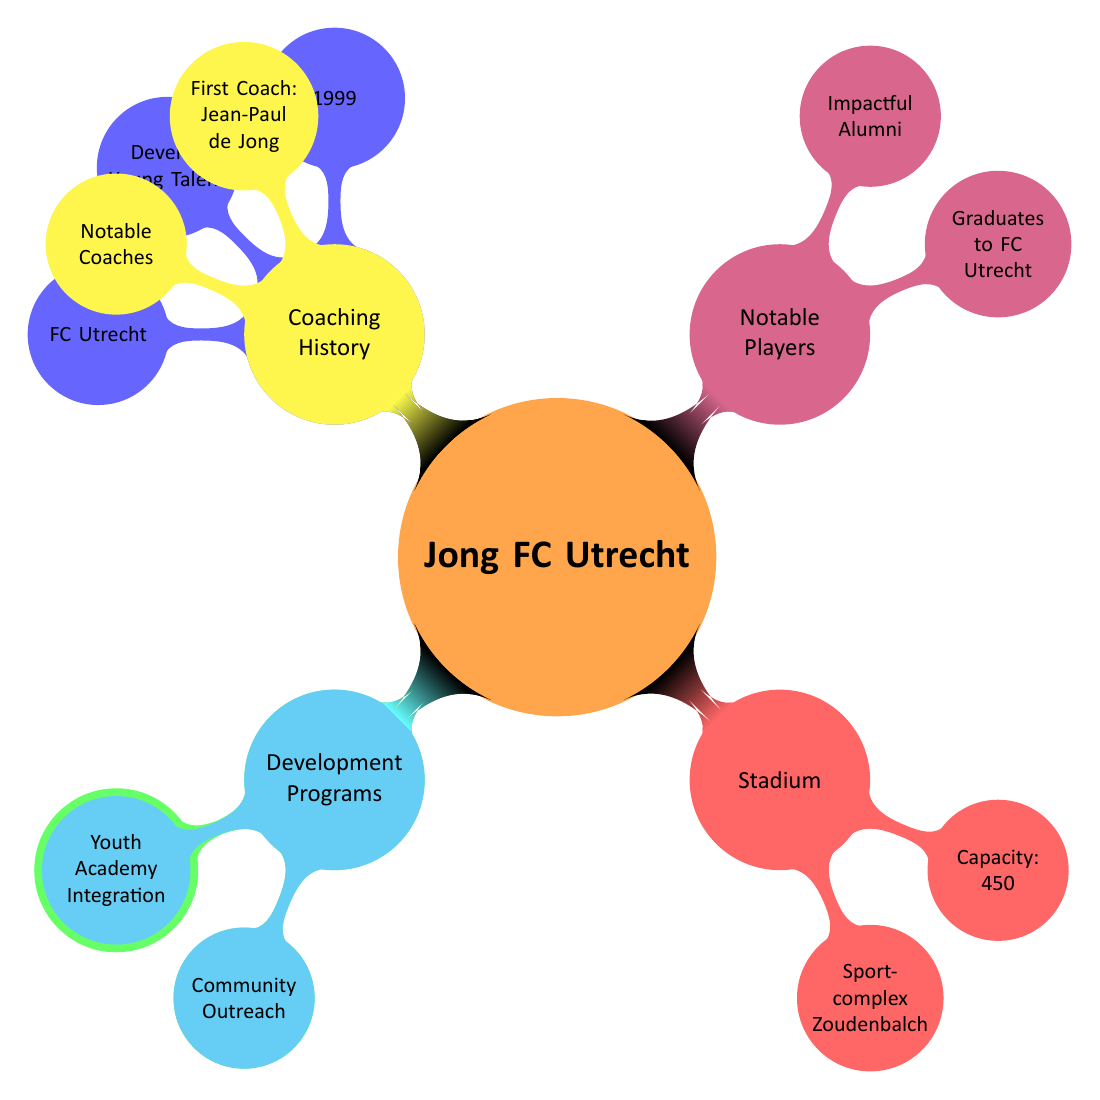What year was Jong FC Utrecht founded? According to the diagram, the year listed under the "Foundation" node is 1999.
Answer: 1999 What is the primary purpose of Jong FC Utrecht? Examining the "Purpose" under the "Foundation" node, it states that the purpose is to "Develop Young Talent."
Answer: Develop Young Talent Where is the stadium of Jong FC Utrecht located? Looking under the "Stadium" node, it specifies the location as "Utrecht."
Answer: Utrecht Who was the first coach of Jong FC Utrecht? The "First Coach" node under "Coaching History" provides the name Jean-Paul de Jong.
Answer: Jean-Paul de Jong What significant achievement did Jong FC Utrecht accomplish in 2016? The "Key Achievements" node mentions "Promotion to Eerste Divisie" in 2016, indicating it was a notable event for the club that year.
Answer: Promotion to Eerste Divisie (2016) Which players are listed as graduates to FC Utrecht? Under the "Notable Players" node, the sub-node "Graduates to FC Utrecht" lists Bart Ramselaar and Rick van der Meer as graduates.
Answer: Bart Ramselaar, Rick van der Meer How many top performers does the diagram list for Jong FC Utrecht? The "Top Performers" node under "Key Achievements" includes two names: Jordi van Stappershoef and Rick Mulder, thus indicating there are two top performers listed.
Answer: 2 What community outreach program is associated with Jong FC Utrecht? Looking under the "Development Programs" node, the sub-node "Community Outreach" specifically mentions "Utrecht Football Talent Programs."
Answer: Utrecht Football Talent Programs Name one impactful alumni of Jong FC Utrecht. Under the "Notable Players" section, the sub-node "Impactful Alumni" lists Giovanni Troupée, making it a valid answer.
Answer: Giovanni Troupée 